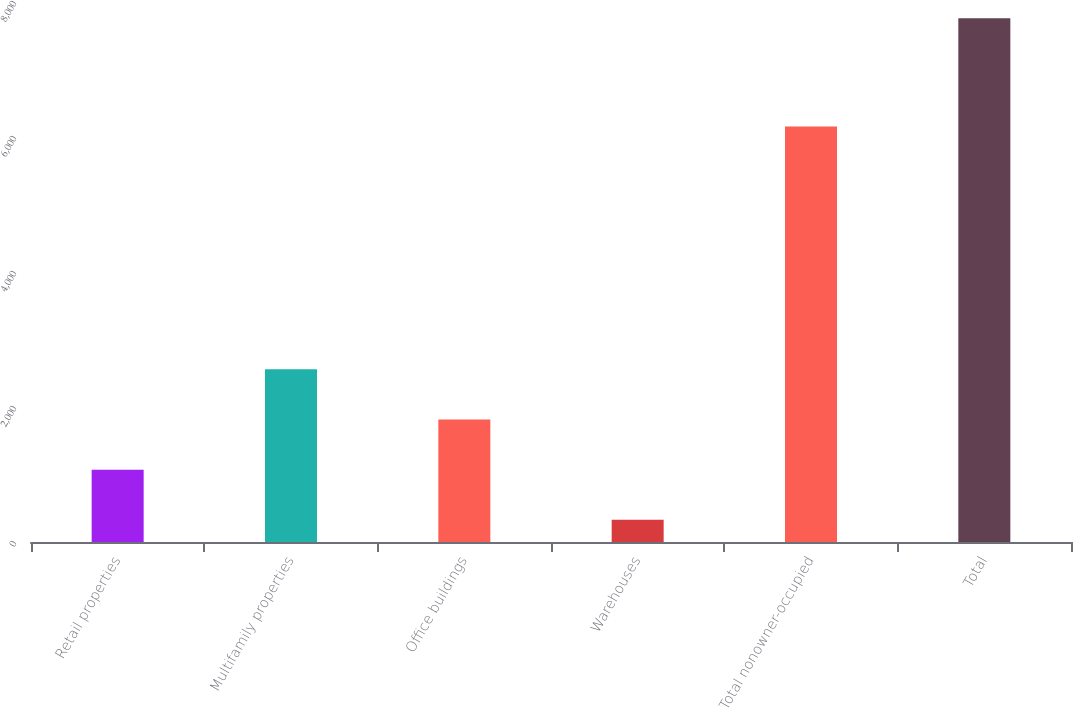Convert chart to OTSL. <chart><loc_0><loc_0><loc_500><loc_500><bar_chart><fcel>Retail properties<fcel>Multifamily properties<fcel>Office buildings<fcel>Warehouses<fcel>Total nonowner-occupied<fcel>Total<nl><fcel>1071.9<fcel>2557.7<fcel>1814.8<fcel>329<fcel>6157<fcel>7758<nl></chart> 